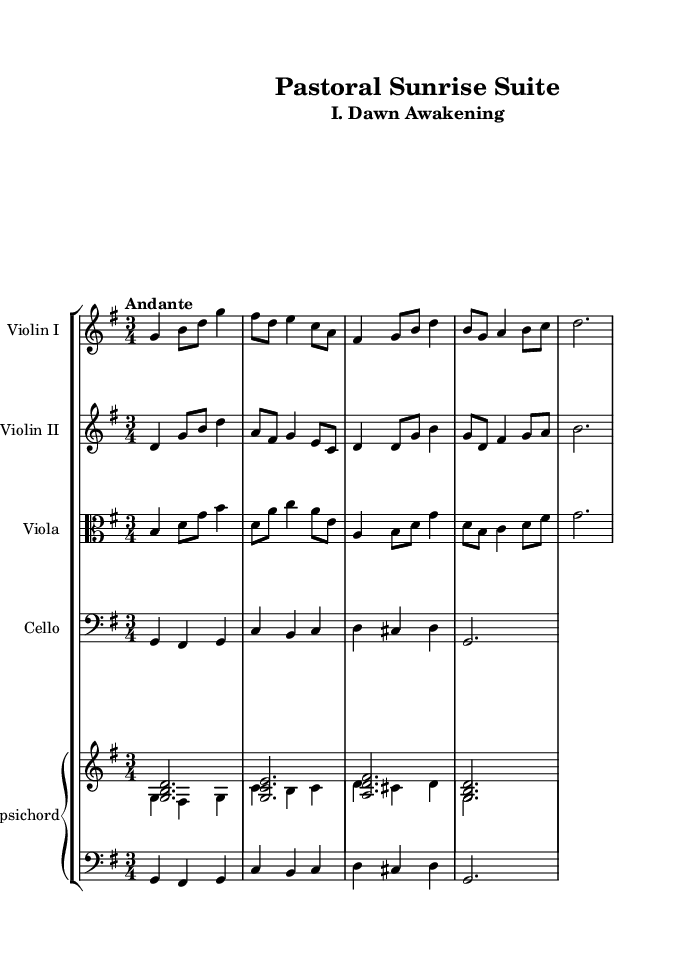what is the key signature of this music? The key signature is G major, which has one sharp (F#). This can be determined by examining the key signature indicated at the beginning of the music score.
Answer: G major what is the time signature of this music? The time signature is 3/4, which indicates three beats per measure, with a quarter note receiving one beat. This is visible at the beginning of the score, right after the key signature.
Answer: 3/4 what is the tempo marking of this piece? The tempo marking is Andante, which describes a moderate pace of walking speed. This is explicitly written above the staff in the score.
Answer: Andante how many measures are in the violin I part? The violin I part contains four measures. This can be determined by counting the number of vertical bar lines in the staff for that instrument.
Answer: four what is the instrument providing harmonic support in this suite? The instrument providing harmonic support is the Harpsichord, indicated at the bottom of the score. The harpsichord plays chords that provide the harmonic framework for the piece.
Answer: Harpsichord how many notes are in the first measure of the viola part? The first measure of the viola part contains four notes (b, d, g, b). This can be counted by analyzing the notation in that measure.
Answer: four what type of piece is this categorized as in the Baroque style? This piece is categorized as a suite, which is a collection of dances or character pieces often connected by a common theme. The structure of this music follows the form characteristic of Baroque suites.
Answer: suite 